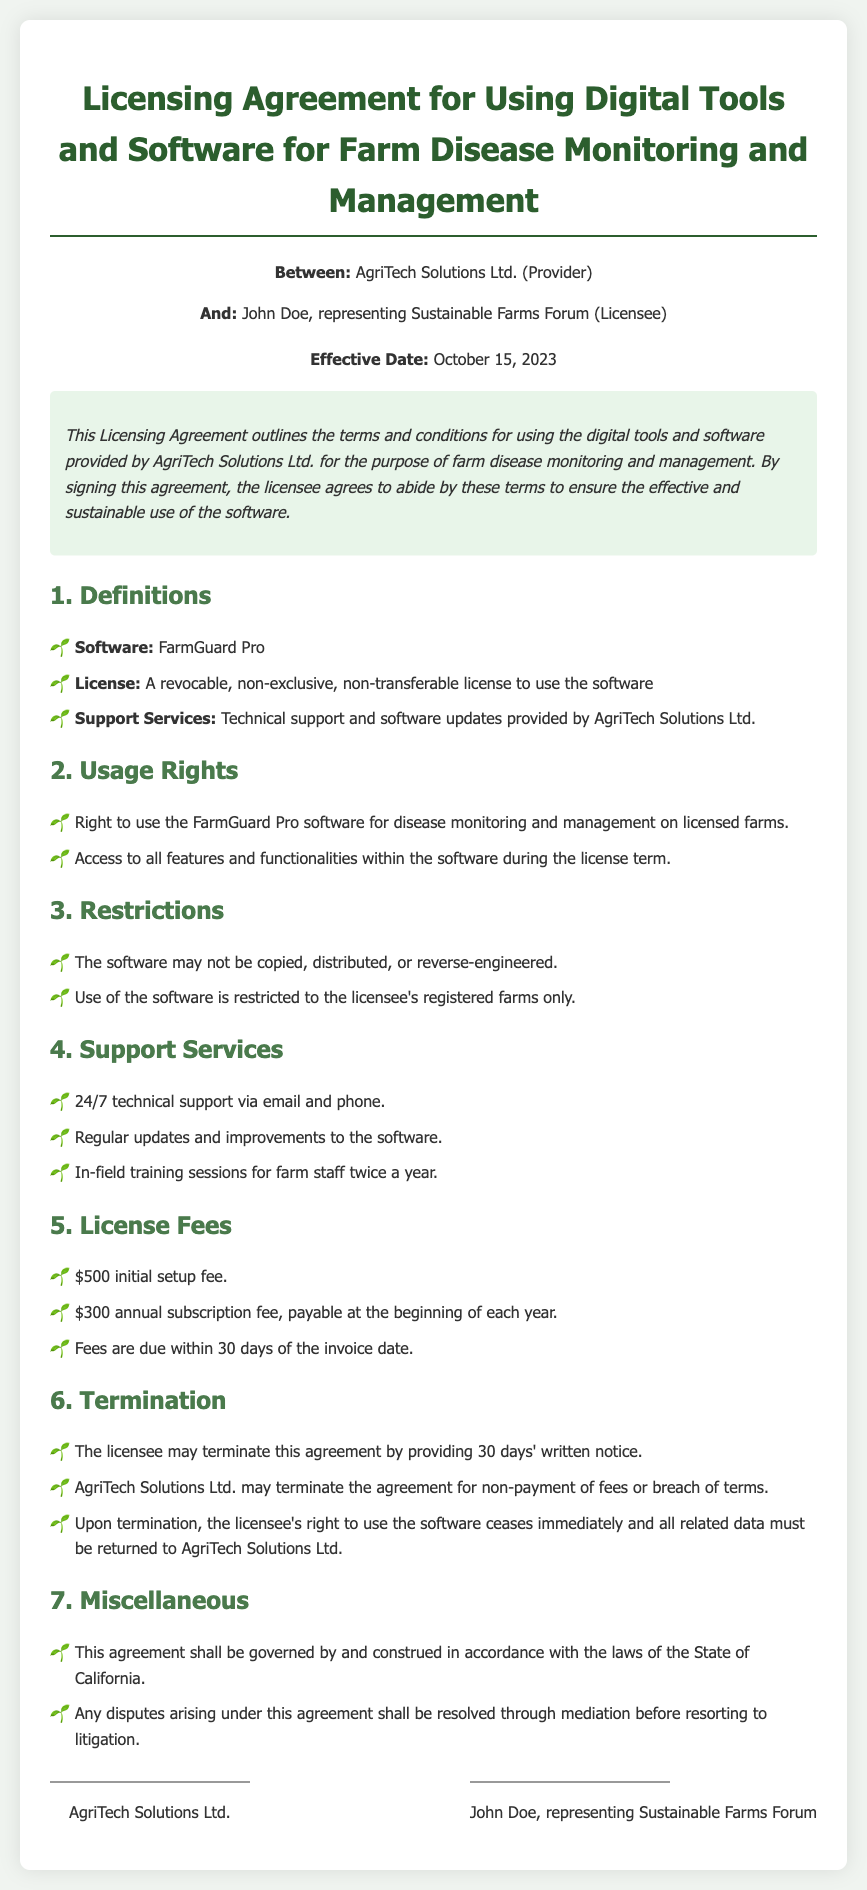What is the name of the software? The software mentioned in the document is FarmGuard Pro.
Answer: FarmGuard Pro Who is the provider of the software? The provider of the software as stated in the document is AgriTech Solutions Ltd.
Answer: AgriTech Solutions Ltd What is the initial setup fee? The document states that the initial setup fee is $500.
Answer: $500 What kind of support is offered? The support services provided include 24/7 technical support.
Answer: 24/7 technical support How long is the license term? The document does not specify a duration for the license term, but it implies annual renewal through the subscription fee.
Answer: Annual What must be done upon termination of the agreement? Upon termination, all related data must be returned to AgriTech Solutions Ltd.
Answer: Return all related data How many training sessions are provided per year? The document indicates that in-field training sessions are provided twice a year.
Answer: Twice a year What is the annual subscription fee? The annual subscription fee mentioned in the document is $300.
Answer: $300 What happens if fees are not paid? The document states that the agreement may be terminated for non-payment of fees.
Answer: Termination of agreement 